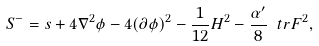Convert formula to latex. <formula><loc_0><loc_0><loc_500><loc_500>S ^ { - } = s + 4 \nabla ^ { 2 } \phi - 4 ( \partial \phi ) ^ { 2 } - \frac { 1 } { 1 2 } H ^ { 2 } - \frac { \alpha ^ { \prime } } { 8 } \ t r F ^ { 2 } ,</formula> 